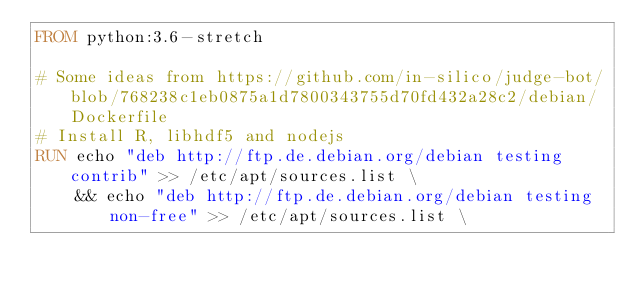<code> <loc_0><loc_0><loc_500><loc_500><_Dockerfile_>FROM python:3.6-stretch

# Some ideas from https://github.com/in-silico/judge-bot/blob/768238c1eb0875a1d7800343755d70fd432a28c2/debian/Dockerfile
# Install R, libhdf5 and nodejs
RUN echo "deb http://ftp.de.debian.org/debian testing contrib" >> /etc/apt/sources.list \
    && echo "deb http://ftp.de.debian.org/debian testing non-free" >> /etc/apt/sources.list \</code> 